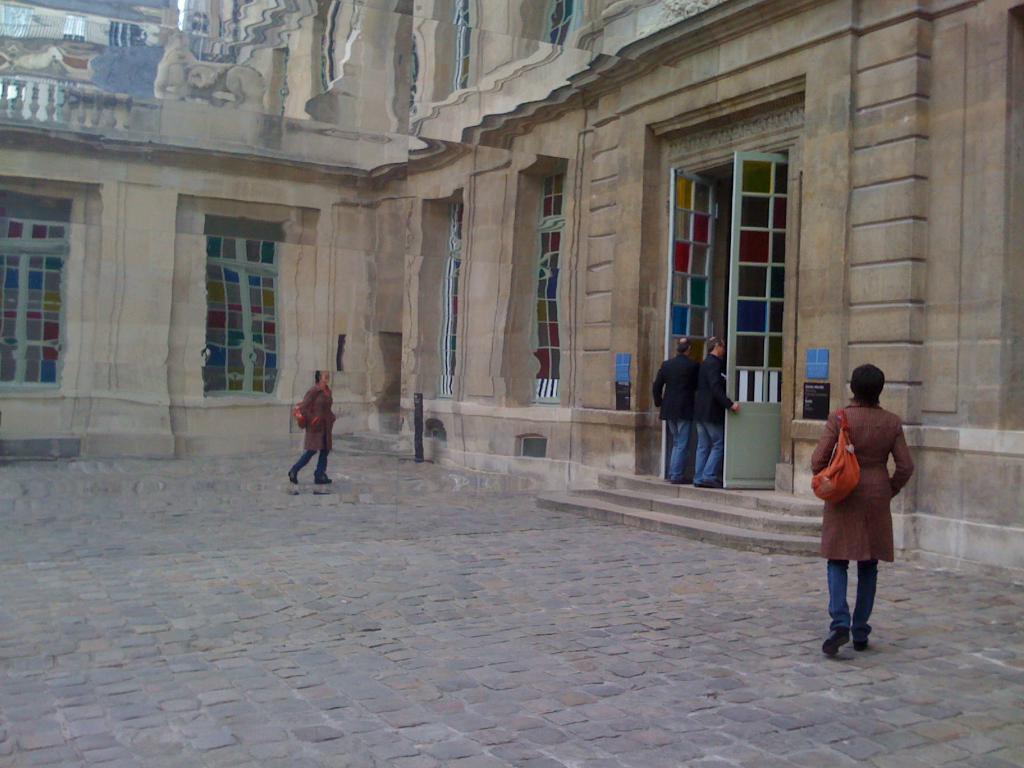How would you summarize this image in a sentence or two? On the right side there is a woman wearing a bag and walking on the floor towards the back side. In front of her there is a building. There are two doors to the wall. Beside the door two men are standing. On the left side there is a mirror. In the mirror, I can see the reflection of this building and woman. 